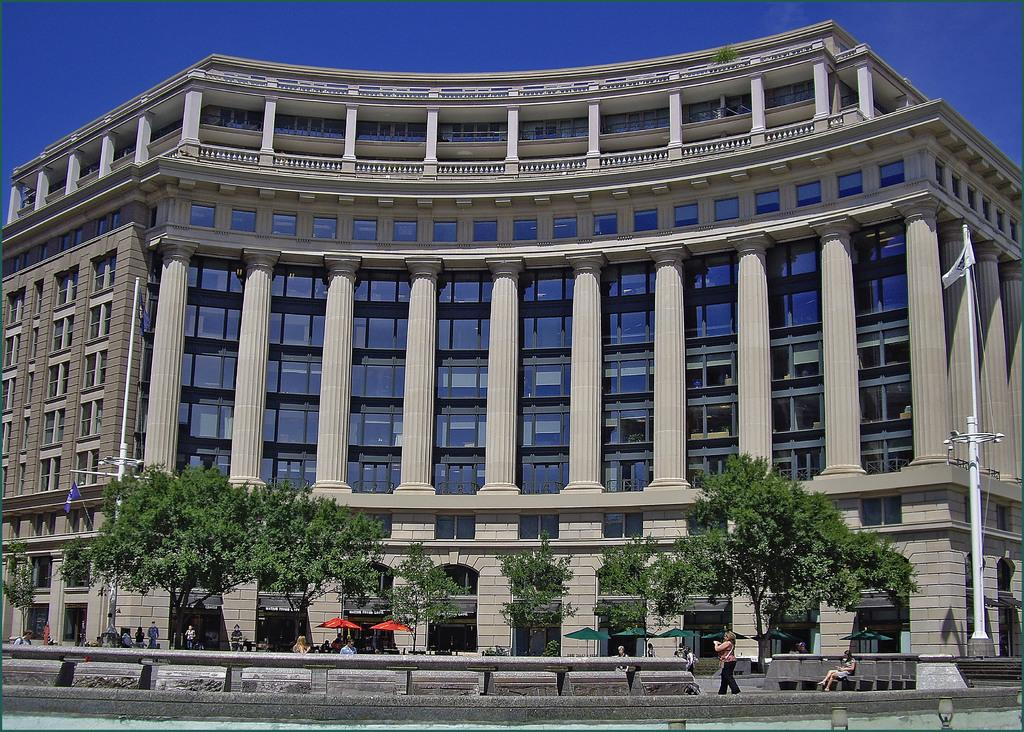What type of structure is present in the image? There is a building in the image. What are the poles used for in the image? The poles are likely used to support flags or other objects in the image. What can be seen attached to the poles? Flags are attached to the poles in the image. What type of vegetation is present in the image? There are trees in the image. What can be used for shade in the image? Umbrellas are present in the image for shade. Who or what is present in the image? There are people in the image. What architectural feature can be seen in the image? Pillars are present in the image. What is the color of the sky in the image? The sky is blue in the image. What type of wood is the ant carrying in the image? There is no ant or wood present in the image. What song is being sung by the people in the image? There is no indication of any song being sung by the people in the image. 